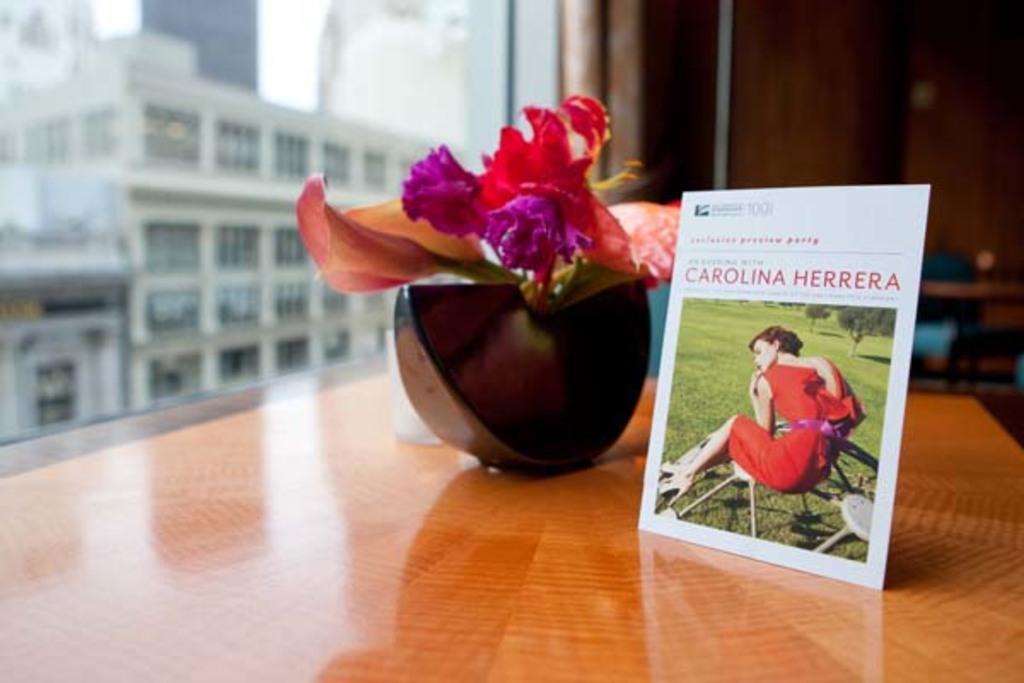Describe this image in one or two sentences. in this picture we see a small hoarding and a flower plant on the table and we see a building from the window 